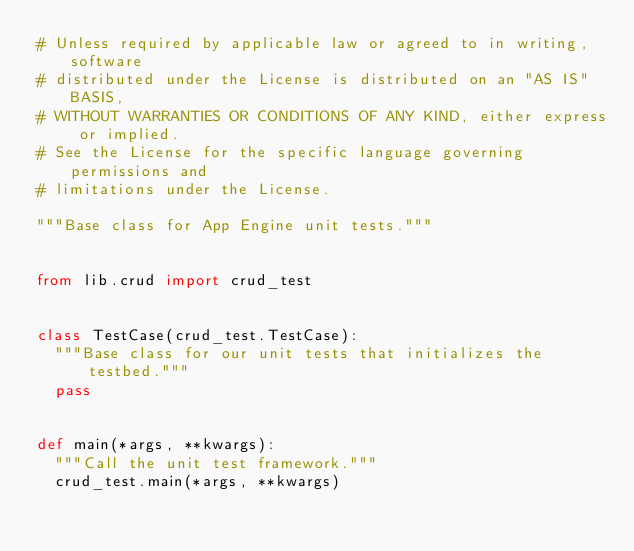Convert code to text. <code><loc_0><loc_0><loc_500><loc_500><_Python_># Unless required by applicable law or agreed to in writing, software
# distributed under the License is distributed on an "AS IS" BASIS,
# WITHOUT WARRANTIES OR CONDITIONS OF ANY KIND, either express or implied.
# See the License for the specific language governing permissions and
# limitations under the License.

"""Base class for App Engine unit tests."""


from lib.crud import crud_test


class TestCase(crud_test.TestCase):
  """Base class for our unit tests that initializes the testbed."""
  pass


def main(*args, **kwargs):
  """Call the unit test framework."""
  crud_test.main(*args, **kwargs)
</code> 